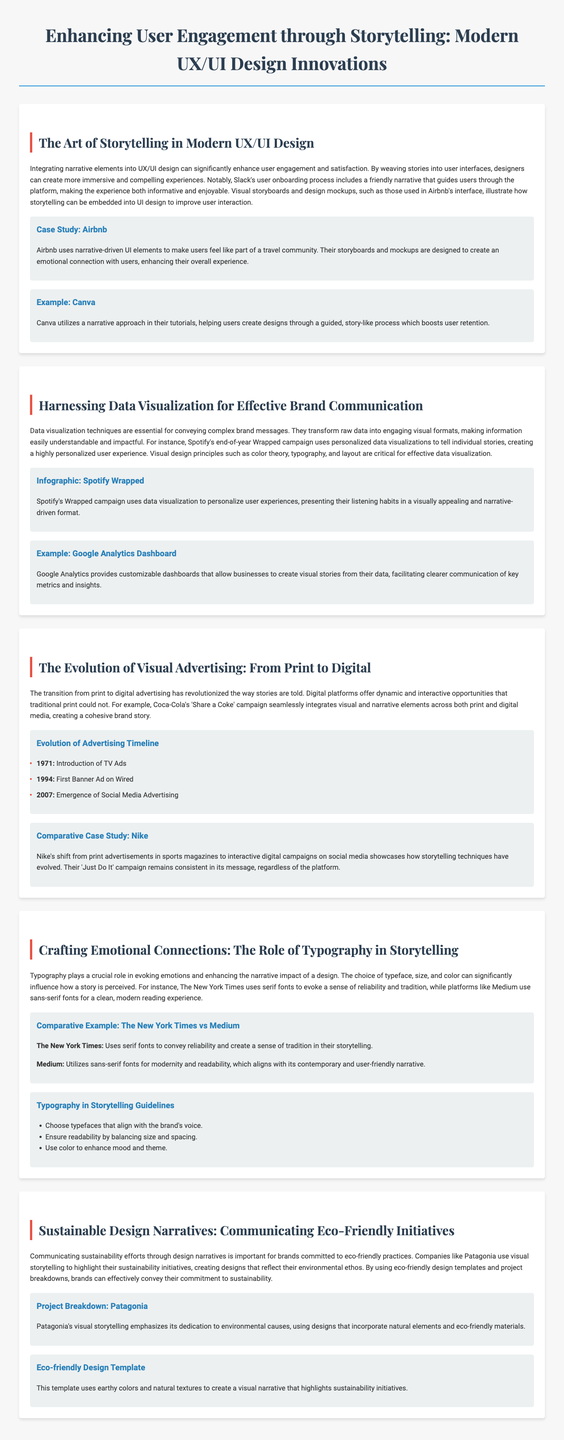What is the title of the whitepaper? The title is at the top of the document, indicating the main focus of the content.
Answer: Enhancing User Engagement through Storytelling: Modern UX/UI Design Innovations Who is the case study focused on in the section about storytelling in UX/UI design? The case study provides specific examples of companies that integrate storytelling into their design, mentioned in that section.
Answer: Airbnb Which campaign uses data visualization to create personalized user experiences? The document discusses various examples of data visualization, noting significant campaigns that illustrate this technique.
Answer: Spotify Wrapped What year marked the introduction of TV Ads according to the advertising evolution timeline? The timeline lists significant milestones in the evolution of advertising, including specific years associated with them.
Answer: 1971 Which two platforms are compared regarding their use of typography in storytelling? The comparative example highlights two different entities known for their typographic choices that affect storytelling.
Answer: The New York Times vs Medium What is one guideline for typography in storytelling mentioned in the document? The guidelines section provides recommendations for using typography effectively in storytelling.
Answer: Ensure readability by balancing size and spacing What company is highlighted for its commitment to sustainability in design narratives? The project breakdown points to a specific company known for its eco-friendly initiatives and visual storytelling.
Answer: Patagonia What role does typography play in storytelling according to the whitepaper? The document elaborates on the emotional impact and narrative enhancement provided by typography in storytelling contexts.
Answer: Evoking emotions 